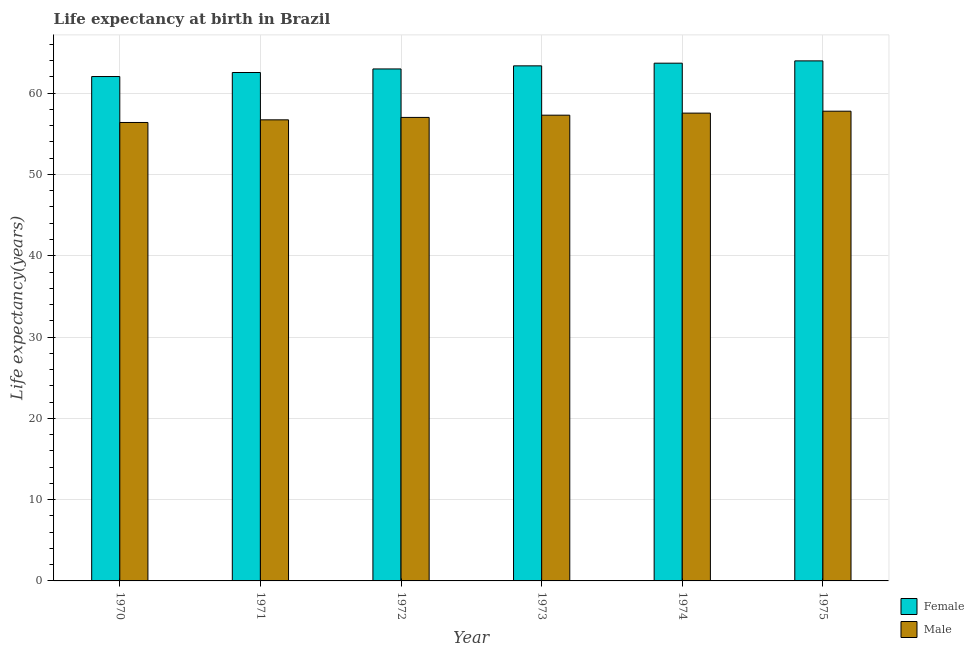Are the number of bars per tick equal to the number of legend labels?
Your answer should be compact. Yes. How many bars are there on the 3rd tick from the right?
Provide a succinct answer. 2. In how many cases, is the number of bars for a given year not equal to the number of legend labels?
Provide a succinct answer. 0. What is the life expectancy(female) in 1971?
Ensure brevity in your answer.  62.54. Across all years, what is the maximum life expectancy(female)?
Your answer should be compact. 63.97. Across all years, what is the minimum life expectancy(female)?
Offer a terse response. 62.05. In which year was the life expectancy(female) maximum?
Offer a very short reply. 1975. In which year was the life expectancy(male) minimum?
Offer a terse response. 1970. What is the total life expectancy(female) in the graph?
Ensure brevity in your answer.  378.58. What is the difference between the life expectancy(female) in 1972 and that in 1975?
Make the answer very short. -0.99. What is the difference between the life expectancy(male) in 1971 and the life expectancy(female) in 1970?
Provide a short and direct response. 0.32. What is the average life expectancy(female) per year?
Ensure brevity in your answer.  63.1. In the year 1974, what is the difference between the life expectancy(male) and life expectancy(female)?
Your answer should be compact. 0. In how many years, is the life expectancy(female) greater than 10 years?
Keep it short and to the point. 6. What is the ratio of the life expectancy(male) in 1972 to that in 1974?
Provide a short and direct response. 0.99. Is the life expectancy(male) in 1971 less than that in 1972?
Give a very brief answer. Yes. Is the difference between the life expectancy(female) in 1971 and 1975 greater than the difference between the life expectancy(male) in 1971 and 1975?
Keep it short and to the point. No. What is the difference between the highest and the second highest life expectancy(male)?
Offer a terse response. 0.24. What is the difference between the highest and the lowest life expectancy(female)?
Offer a very short reply. 1.93. Is the sum of the life expectancy(female) in 1973 and 1975 greater than the maximum life expectancy(male) across all years?
Your answer should be compact. Yes. What does the 1st bar from the left in 1971 represents?
Make the answer very short. Female. What does the 1st bar from the right in 1973 represents?
Make the answer very short. Male. How many bars are there?
Make the answer very short. 12. Are all the bars in the graph horizontal?
Your answer should be compact. No. What is the difference between two consecutive major ticks on the Y-axis?
Give a very brief answer. 10. How many legend labels are there?
Provide a short and direct response. 2. How are the legend labels stacked?
Offer a very short reply. Vertical. What is the title of the graph?
Offer a very short reply. Life expectancy at birth in Brazil. Does "Infant" appear as one of the legend labels in the graph?
Offer a terse response. No. What is the label or title of the Y-axis?
Your answer should be very brief. Life expectancy(years). What is the Life expectancy(years) in Female in 1970?
Your response must be concise. 62.05. What is the Life expectancy(years) of Male in 1970?
Offer a very short reply. 56.39. What is the Life expectancy(years) of Female in 1971?
Your answer should be compact. 62.54. What is the Life expectancy(years) of Male in 1971?
Give a very brief answer. 56.72. What is the Life expectancy(years) of Female in 1972?
Ensure brevity in your answer.  62.98. What is the Life expectancy(years) of Male in 1972?
Provide a short and direct response. 57.02. What is the Life expectancy(years) in Female in 1973?
Your response must be concise. 63.36. What is the Life expectancy(years) of Male in 1973?
Keep it short and to the point. 57.29. What is the Life expectancy(years) in Female in 1974?
Ensure brevity in your answer.  63.69. What is the Life expectancy(years) in Male in 1974?
Offer a very short reply. 57.55. What is the Life expectancy(years) in Female in 1975?
Your answer should be compact. 63.97. What is the Life expectancy(years) in Male in 1975?
Your response must be concise. 57.78. Across all years, what is the maximum Life expectancy(years) in Female?
Your answer should be compact. 63.97. Across all years, what is the maximum Life expectancy(years) of Male?
Your answer should be compact. 57.78. Across all years, what is the minimum Life expectancy(years) of Female?
Provide a succinct answer. 62.05. Across all years, what is the minimum Life expectancy(years) in Male?
Your response must be concise. 56.39. What is the total Life expectancy(years) in Female in the graph?
Keep it short and to the point. 378.58. What is the total Life expectancy(years) of Male in the graph?
Ensure brevity in your answer.  342.75. What is the difference between the Life expectancy(years) of Female in 1970 and that in 1971?
Offer a very short reply. -0.49. What is the difference between the Life expectancy(years) in Male in 1970 and that in 1971?
Your response must be concise. -0.32. What is the difference between the Life expectancy(years) of Female in 1970 and that in 1972?
Offer a terse response. -0.93. What is the difference between the Life expectancy(years) of Male in 1970 and that in 1972?
Your answer should be compact. -0.62. What is the difference between the Life expectancy(years) in Female in 1970 and that in 1973?
Offer a terse response. -1.31. What is the difference between the Life expectancy(years) of Male in 1970 and that in 1973?
Provide a short and direct response. -0.9. What is the difference between the Life expectancy(years) of Female in 1970 and that in 1974?
Provide a short and direct response. -1.64. What is the difference between the Life expectancy(years) in Male in 1970 and that in 1974?
Give a very brief answer. -1.15. What is the difference between the Life expectancy(years) in Female in 1970 and that in 1975?
Offer a very short reply. -1.93. What is the difference between the Life expectancy(years) of Male in 1970 and that in 1975?
Your response must be concise. -1.39. What is the difference between the Life expectancy(years) in Female in 1971 and that in 1972?
Give a very brief answer. -0.44. What is the difference between the Life expectancy(years) in Male in 1971 and that in 1972?
Your answer should be compact. -0.3. What is the difference between the Life expectancy(years) in Female in 1971 and that in 1973?
Make the answer very short. -0.82. What is the difference between the Life expectancy(years) of Male in 1971 and that in 1973?
Provide a short and direct response. -0.57. What is the difference between the Life expectancy(years) of Female in 1971 and that in 1974?
Offer a terse response. -1.15. What is the difference between the Life expectancy(years) in Male in 1971 and that in 1974?
Your answer should be very brief. -0.83. What is the difference between the Life expectancy(years) in Female in 1971 and that in 1975?
Keep it short and to the point. -1.43. What is the difference between the Life expectancy(years) in Male in 1971 and that in 1975?
Give a very brief answer. -1.06. What is the difference between the Life expectancy(years) in Female in 1972 and that in 1973?
Ensure brevity in your answer.  -0.38. What is the difference between the Life expectancy(years) in Male in 1972 and that in 1973?
Make the answer very short. -0.28. What is the difference between the Life expectancy(years) in Female in 1972 and that in 1974?
Provide a short and direct response. -0.71. What is the difference between the Life expectancy(years) in Male in 1972 and that in 1974?
Provide a succinct answer. -0.53. What is the difference between the Life expectancy(years) of Female in 1972 and that in 1975?
Offer a terse response. -0.99. What is the difference between the Life expectancy(years) of Male in 1972 and that in 1975?
Your answer should be compact. -0.76. What is the difference between the Life expectancy(years) of Female in 1973 and that in 1974?
Offer a very short reply. -0.33. What is the difference between the Life expectancy(years) in Male in 1973 and that in 1974?
Your answer should be compact. -0.25. What is the difference between the Life expectancy(years) of Female in 1973 and that in 1975?
Provide a succinct answer. -0.61. What is the difference between the Life expectancy(years) in Male in 1973 and that in 1975?
Give a very brief answer. -0.49. What is the difference between the Life expectancy(years) of Female in 1974 and that in 1975?
Make the answer very short. -0.28. What is the difference between the Life expectancy(years) in Male in 1974 and that in 1975?
Your answer should be very brief. -0.24. What is the difference between the Life expectancy(years) of Female in 1970 and the Life expectancy(years) of Male in 1971?
Keep it short and to the point. 5.33. What is the difference between the Life expectancy(years) of Female in 1970 and the Life expectancy(years) of Male in 1972?
Your answer should be compact. 5.03. What is the difference between the Life expectancy(years) of Female in 1970 and the Life expectancy(years) of Male in 1973?
Keep it short and to the point. 4.75. What is the difference between the Life expectancy(years) in Female in 1970 and the Life expectancy(years) in Male in 1974?
Ensure brevity in your answer.  4.5. What is the difference between the Life expectancy(years) in Female in 1970 and the Life expectancy(years) in Male in 1975?
Offer a terse response. 4.26. What is the difference between the Life expectancy(years) in Female in 1971 and the Life expectancy(years) in Male in 1972?
Provide a short and direct response. 5.52. What is the difference between the Life expectancy(years) in Female in 1971 and the Life expectancy(years) in Male in 1973?
Your answer should be very brief. 5.25. What is the difference between the Life expectancy(years) of Female in 1971 and the Life expectancy(years) of Male in 1974?
Make the answer very short. 5. What is the difference between the Life expectancy(years) in Female in 1971 and the Life expectancy(years) in Male in 1975?
Make the answer very short. 4.76. What is the difference between the Life expectancy(years) in Female in 1972 and the Life expectancy(years) in Male in 1973?
Provide a succinct answer. 5.69. What is the difference between the Life expectancy(years) of Female in 1972 and the Life expectancy(years) of Male in 1974?
Offer a very short reply. 5.43. What is the difference between the Life expectancy(years) in Female in 1972 and the Life expectancy(years) in Male in 1975?
Your response must be concise. 5.2. What is the difference between the Life expectancy(years) in Female in 1973 and the Life expectancy(years) in Male in 1974?
Ensure brevity in your answer.  5.81. What is the difference between the Life expectancy(years) of Female in 1973 and the Life expectancy(years) of Male in 1975?
Offer a very short reply. 5.58. What is the difference between the Life expectancy(years) in Female in 1974 and the Life expectancy(years) in Male in 1975?
Give a very brief answer. 5.91. What is the average Life expectancy(years) in Female per year?
Provide a succinct answer. 63.1. What is the average Life expectancy(years) in Male per year?
Your answer should be compact. 57.12. In the year 1970, what is the difference between the Life expectancy(years) in Female and Life expectancy(years) in Male?
Provide a short and direct response. 5.65. In the year 1971, what is the difference between the Life expectancy(years) in Female and Life expectancy(years) in Male?
Your answer should be very brief. 5.82. In the year 1972, what is the difference between the Life expectancy(years) of Female and Life expectancy(years) of Male?
Offer a terse response. 5.96. In the year 1973, what is the difference between the Life expectancy(years) of Female and Life expectancy(years) of Male?
Offer a terse response. 6.07. In the year 1974, what is the difference between the Life expectancy(years) in Female and Life expectancy(years) in Male?
Provide a short and direct response. 6.14. In the year 1975, what is the difference between the Life expectancy(years) of Female and Life expectancy(years) of Male?
Offer a very short reply. 6.19. What is the ratio of the Life expectancy(years) of Female in 1970 to that in 1972?
Keep it short and to the point. 0.99. What is the ratio of the Life expectancy(years) of Male in 1970 to that in 1972?
Make the answer very short. 0.99. What is the ratio of the Life expectancy(years) of Female in 1970 to that in 1973?
Your response must be concise. 0.98. What is the ratio of the Life expectancy(years) of Male in 1970 to that in 1973?
Give a very brief answer. 0.98. What is the ratio of the Life expectancy(years) of Female in 1970 to that in 1974?
Ensure brevity in your answer.  0.97. What is the ratio of the Life expectancy(years) in Female in 1970 to that in 1975?
Your response must be concise. 0.97. What is the ratio of the Life expectancy(years) in Male in 1970 to that in 1975?
Your answer should be very brief. 0.98. What is the ratio of the Life expectancy(years) in Male in 1971 to that in 1972?
Give a very brief answer. 0.99. What is the ratio of the Life expectancy(years) in Female in 1971 to that in 1973?
Your response must be concise. 0.99. What is the ratio of the Life expectancy(years) of Female in 1971 to that in 1974?
Provide a short and direct response. 0.98. What is the ratio of the Life expectancy(years) of Male in 1971 to that in 1974?
Provide a succinct answer. 0.99. What is the ratio of the Life expectancy(years) of Female in 1971 to that in 1975?
Provide a succinct answer. 0.98. What is the ratio of the Life expectancy(years) in Male in 1971 to that in 1975?
Provide a succinct answer. 0.98. What is the ratio of the Life expectancy(years) of Male in 1972 to that in 1973?
Offer a very short reply. 1. What is the ratio of the Life expectancy(years) in Female in 1972 to that in 1974?
Make the answer very short. 0.99. What is the ratio of the Life expectancy(years) in Male in 1972 to that in 1974?
Make the answer very short. 0.99. What is the ratio of the Life expectancy(years) of Female in 1972 to that in 1975?
Your answer should be compact. 0.98. What is the ratio of the Life expectancy(years) of Male in 1972 to that in 1975?
Keep it short and to the point. 0.99. What is the ratio of the Life expectancy(years) in Male in 1973 to that in 1974?
Give a very brief answer. 1. What is the ratio of the Life expectancy(years) of Female in 1973 to that in 1975?
Your answer should be compact. 0.99. What is the ratio of the Life expectancy(years) of Male in 1973 to that in 1975?
Your answer should be very brief. 0.99. What is the difference between the highest and the second highest Life expectancy(years) of Female?
Keep it short and to the point. 0.28. What is the difference between the highest and the second highest Life expectancy(years) in Male?
Give a very brief answer. 0.24. What is the difference between the highest and the lowest Life expectancy(years) of Female?
Keep it short and to the point. 1.93. What is the difference between the highest and the lowest Life expectancy(years) of Male?
Give a very brief answer. 1.39. 